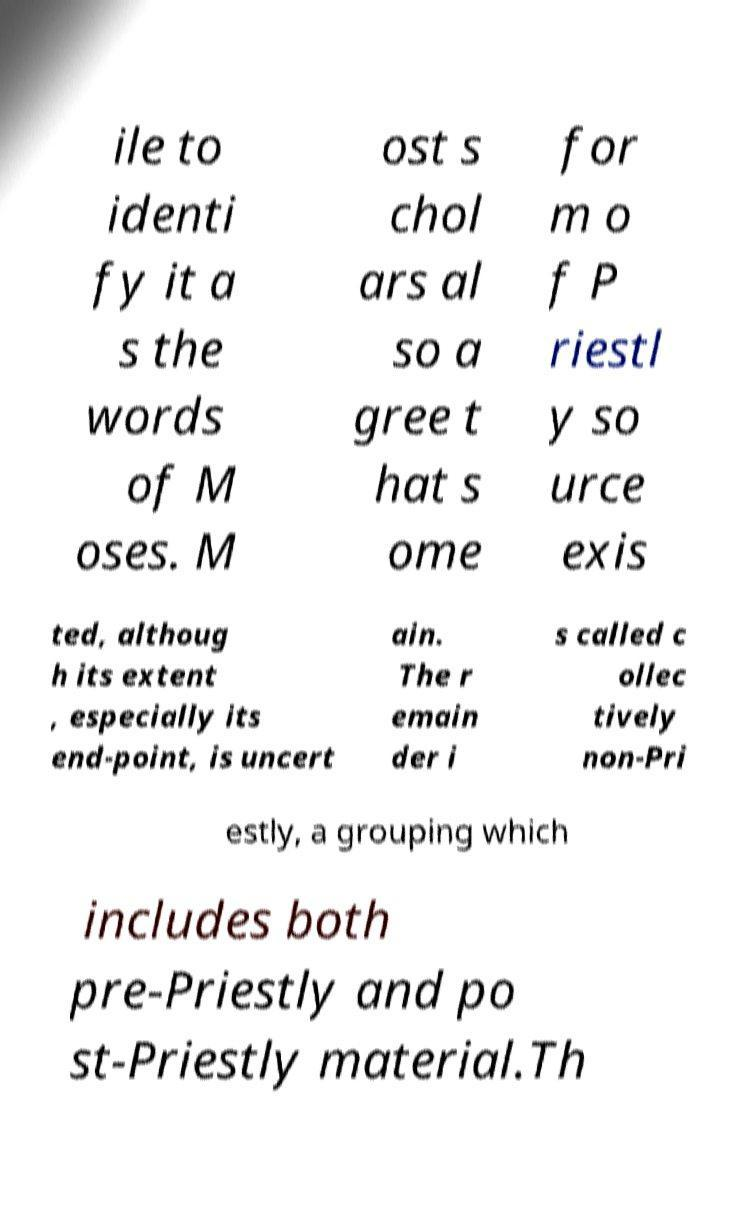For documentation purposes, I need the text within this image transcribed. Could you provide that? ile to identi fy it a s the words of M oses. M ost s chol ars al so a gree t hat s ome for m o f P riestl y so urce exis ted, althoug h its extent , especially its end-point, is uncert ain. The r emain der i s called c ollec tively non-Pri estly, a grouping which includes both pre-Priestly and po st-Priestly material.Th 